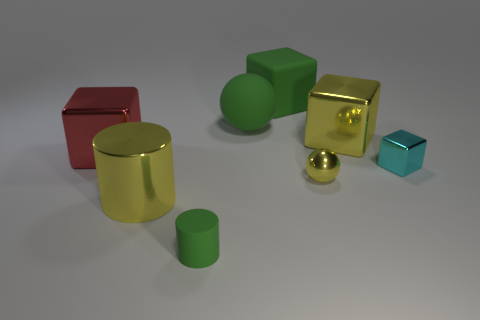Are there an equal number of small shiny balls and tiny brown metallic cylinders?
Your answer should be compact. No. Do the matte cylinder and the matte sphere have the same size?
Offer a very short reply. No. There is a big sphere on the left side of the large rubber thing behind the green sphere; is there a tiny cyan cube in front of it?
Provide a short and direct response. Yes. The metal cylinder is what size?
Your answer should be very brief. Large. How many other red blocks are the same size as the red metal block?
Your answer should be compact. 0. What material is the yellow object that is the same shape as the cyan shiny object?
Make the answer very short. Metal. What shape is the metal object that is in front of the red object and to the left of the tiny yellow metal ball?
Provide a succinct answer. Cylinder. There is a green object in front of the red thing; what shape is it?
Offer a terse response. Cylinder. How many large things are to the left of the green cylinder and right of the green cylinder?
Offer a terse response. 0. There is a rubber cylinder; is its size the same as the shiny object left of the yellow cylinder?
Your answer should be very brief. No. 